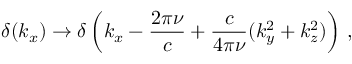<formula> <loc_0><loc_0><loc_500><loc_500>\delta ( k _ { x } ) \to \delta \left ( k _ { x } - \frac { 2 \pi \nu } { c } + \frac { c } { 4 \pi \nu } ( k _ { y } ^ { 2 } + k _ { z } ^ { 2 } ) \right ) \, ,</formula> 